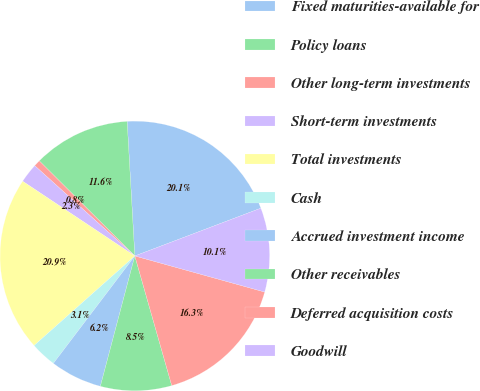Convert chart. <chart><loc_0><loc_0><loc_500><loc_500><pie_chart><fcel>Fixed maturities-available for<fcel>Policy loans<fcel>Other long-term investments<fcel>Short-term investments<fcel>Total investments<fcel>Cash<fcel>Accrued investment income<fcel>Other receivables<fcel>Deferred acquisition costs<fcel>Goodwill<nl><fcel>20.14%<fcel>11.63%<fcel>0.78%<fcel>2.33%<fcel>20.92%<fcel>3.11%<fcel>6.21%<fcel>8.53%<fcel>16.27%<fcel>10.08%<nl></chart> 